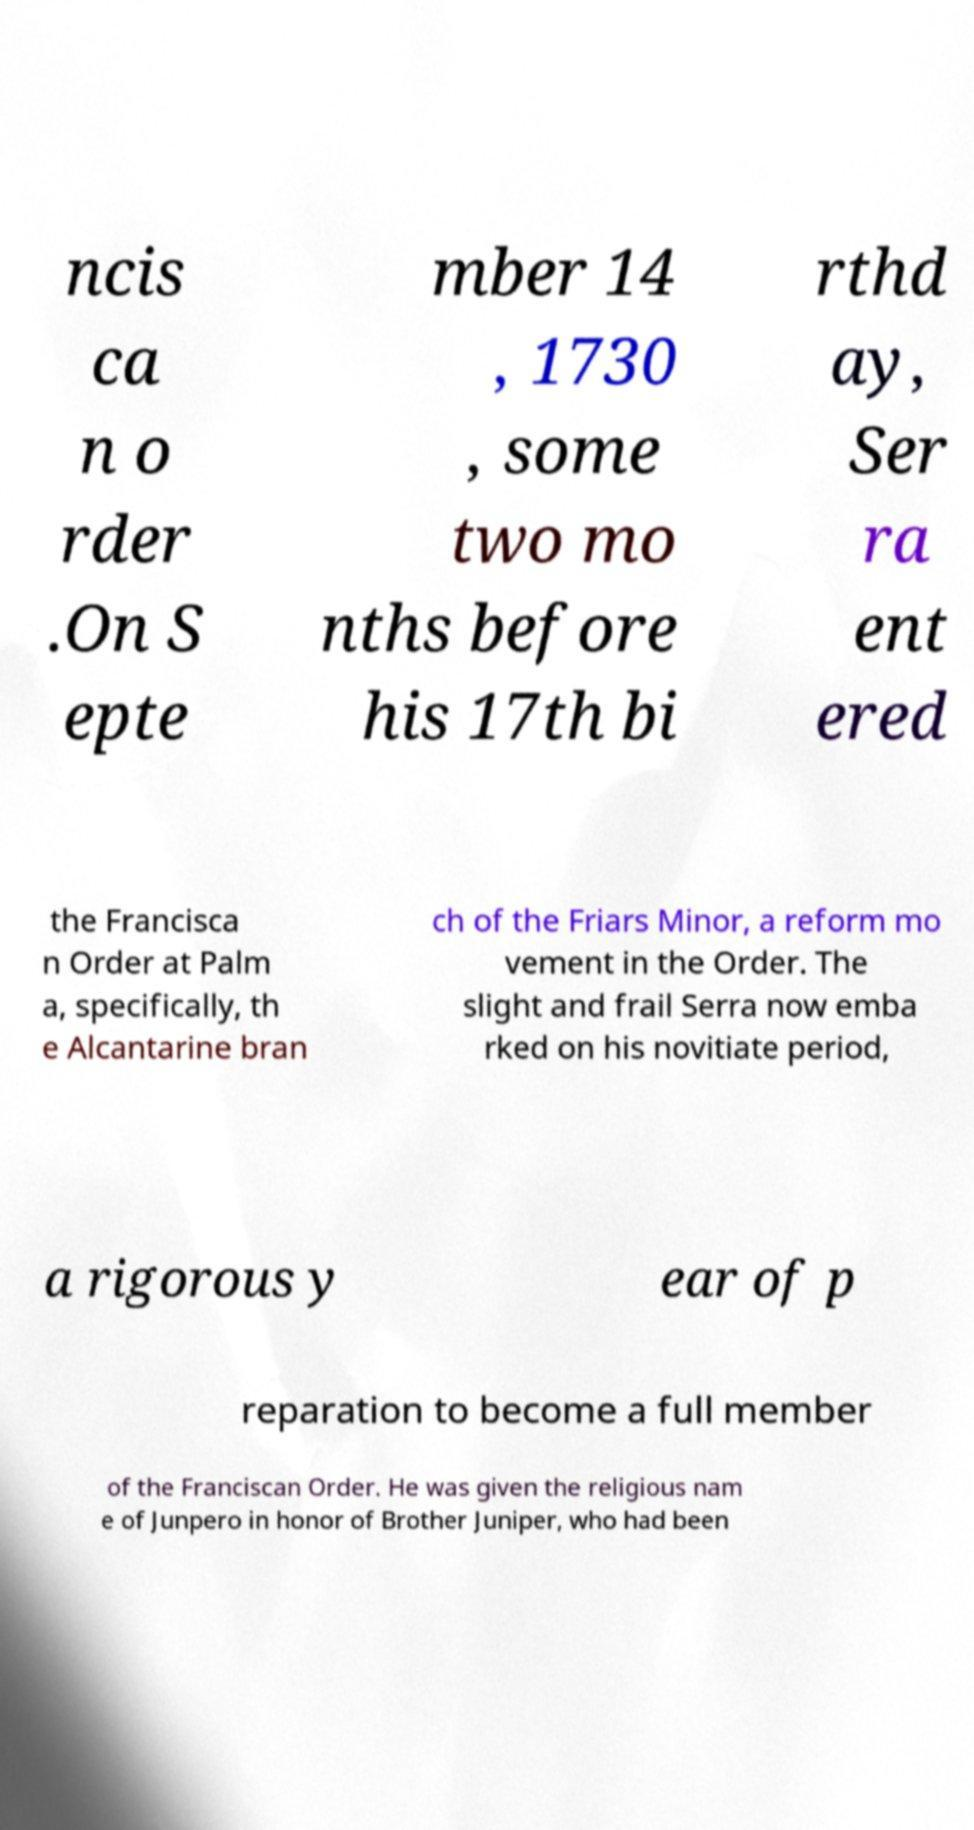Could you extract and type out the text from this image? ncis ca n o rder .On S epte mber 14 , 1730 , some two mo nths before his 17th bi rthd ay, Ser ra ent ered the Francisca n Order at Palm a, specifically, th e Alcantarine bran ch of the Friars Minor, a reform mo vement in the Order. The slight and frail Serra now emba rked on his novitiate period, a rigorous y ear of p reparation to become a full member of the Franciscan Order. He was given the religious nam e of Junpero in honor of Brother Juniper, who had been 